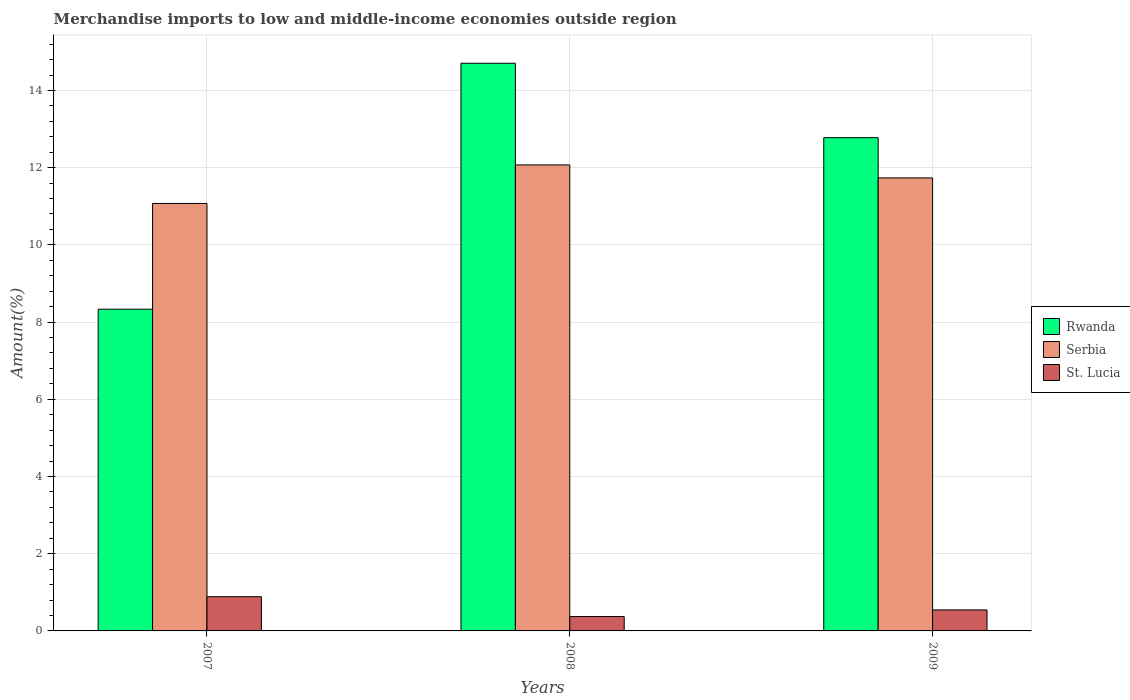How many different coloured bars are there?
Your response must be concise. 3. Are the number of bars per tick equal to the number of legend labels?
Your answer should be compact. Yes. Are the number of bars on each tick of the X-axis equal?
Provide a short and direct response. Yes. How many bars are there on the 1st tick from the left?
Give a very brief answer. 3. How many bars are there on the 2nd tick from the right?
Offer a terse response. 3. What is the label of the 3rd group of bars from the left?
Offer a terse response. 2009. In how many cases, is the number of bars for a given year not equal to the number of legend labels?
Offer a terse response. 0. What is the percentage of amount earned from merchandise imports in St. Lucia in 2007?
Ensure brevity in your answer.  0.89. Across all years, what is the maximum percentage of amount earned from merchandise imports in St. Lucia?
Your answer should be very brief. 0.89. Across all years, what is the minimum percentage of amount earned from merchandise imports in Serbia?
Make the answer very short. 11.07. In which year was the percentage of amount earned from merchandise imports in Serbia minimum?
Ensure brevity in your answer.  2007. What is the total percentage of amount earned from merchandise imports in Serbia in the graph?
Your response must be concise. 34.88. What is the difference between the percentage of amount earned from merchandise imports in St. Lucia in 2008 and that in 2009?
Your response must be concise. -0.17. What is the difference between the percentage of amount earned from merchandise imports in St. Lucia in 2008 and the percentage of amount earned from merchandise imports in Rwanda in 2009?
Your answer should be very brief. -12.4. What is the average percentage of amount earned from merchandise imports in Serbia per year?
Provide a short and direct response. 11.63. In the year 2009, what is the difference between the percentage of amount earned from merchandise imports in Serbia and percentage of amount earned from merchandise imports in St. Lucia?
Provide a succinct answer. 11.19. What is the ratio of the percentage of amount earned from merchandise imports in Rwanda in 2008 to that in 2009?
Provide a succinct answer. 1.15. Is the difference between the percentage of amount earned from merchandise imports in Serbia in 2007 and 2009 greater than the difference between the percentage of amount earned from merchandise imports in St. Lucia in 2007 and 2009?
Provide a succinct answer. No. What is the difference between the highest and the second highest percentage of amount earned from merchandise imports in Rwanda?
Your response must be concise. 1.93. What is the difference between the highest and the lowest percentage of amount earned from merchandise imports in Rwanda?
Make the answer very short. 6.37. In how many years, is the percentage of amount earned from merchandise imports in St. Lucia greater than the average percentage of amount earned from merchandise imports in St. Lucia taken over all years?
Your answer should be compact. 1. Is the sum of the percentage of amount earned from merchandise imports in St. Lucia in 2007 and 2008 greater than the maximum percentage of amount earned from merchandise imports in Rwanda across all years?
Your response must be concise. No. What does the 3rd bar from the left in 2008 represents?
Your answer should be compact. St. Lucia. What does the 1st bar from the right in 2008 represents?
Offer a terse response. St. Lucia. What is the difference between two consecutive major ticks on the Y-axis?
Offer a terse response. 2. Are the values on the major ticks of Y-axis written in scientific E-notation?
Your response must be concise. No. Does the graph contain any zero values?
Your answer should be very brief. No. Where does the legend appear in the graph?
Offer a terse response. Center right. How many legend labels are there?
Provide a succinct answer. 3. What is the title of the graph?
Offer a terse response. Merchandise imports to low and middle-income economies outside region. What is the label or title of the Y-axis?
Your answer should be very brief. Amount(%). What is the Amount(%) in Rwanda in 2007?
Ensure brevity in your answer.  8.33. What is the Amount(%) in Serbia in 2007?
Give a very brief answer. 11.07. What is the Amount(%) in St. Lucia in 2007?
Make the answer very short. 0.89. What is the Amount(%) in Rwanda in 2008?
Your answer should be very brief. 14.7. What is the Amount(%) in Serbia in 2008?
Give a very brief answer. 12.07. What is the Amount(%) in St. Lucia in 2008?
Your response must be concise. 0.37. What is the Amount(%) of Rwanda in 2009?
Ensure brevity in your answer.  12.78. What is the Amount(%) in Serbia in 2009?
Your answer should be very brief. 11.73. What is the Amount(%) of St. Lucia in 2009?
Make the answer very short. 0.54. Across all years, what is the maximum Amount(%) in Rwanda?
Keep it short and to the point. 14.7. Across all years, what is the maximum Amount(%) in Serbia?
Provide a short and direct response. 12.07. Across all years, what is the maximum Amount(%) in St. Lucia?
Provide a succinct answer. 0.89. Across all years, what is the minimum Amount(%) in Rwanda?
Offer a terse response. 8.33. Across all years, what is the minimum Amount(%) of Serbia?
Provide a succinct answer. 11.07. Across all years, what is the minimum Amount(%) of St. Lucia?
Your answer should be very brief. 0.37. What is the total Amount(%) of Rwanda in the graph?
Offer a very short reply. 35.81. What is the total Amount(%) of Serbia in the graph?
Your answer should be very brief. 34.88. What is the total Amount(%) of St. Lucia in the graph?
Your response must be concise. 1.8. What is the difference between the Amount(%) in Rwanda in 2007 and that in 2008?
Provide a short and direct response. -6.37. What is the difference between the Amount(%) of Serbia in 2007 and that in 2008?
Make the answer very short. -1. What is the difference between the Amount(%) in St. Lucia in 2007 and that in 2008?
Offer a very short reply. 0.51. What is the difference between the Amount(%) of Rwanda in 2007 and that in 2009?
Make the answer very short. -4.44. What is the difference between the Amount(%) in Serbia in 2007 and that in 2009?
Provide a short and direct response. -0.66. What is the difference between the Amount(%) in St. Lucia in 2007 and that in 2009?
Ensure brevity in your answer.  0.34. What is the difference between the Amount(%) in Rwanda in 2008 and that in 2009?
Your answer should be very brief. 1.93. What is the difference between the Amount(%) of Serbia in 2008 and that in 2009?
Your answer should be compact. 0.34. What is the difference between the Amount(%) of St. Lucia in 2008 and that in 2009?
Offer a terse response. -0.17. What is the difference between the Amount(%) in Rwanda in 2007 and the Amount(%) in Serbia in 2008?
Make the answer very short. -3.74. What is the difference between the Amount(%) of Rwanda in 2007 and the Amount(%) of St. Lucia in 2008?
Your answer should be very brief. 7.96. What is the difference between the Amount(%) in Serbia in 2007 and the Amount(%) in St. Lucia in 2008?
Ensure brevity in your answer.  10.7. What is the difference between the Amount(%) of Rwanda in 2007 and the Amount(%) of Serbia in 2009?
Give a very brief answer. -3.4. What is the difference between the Amount(%) in Rwanda in 2007 and the Amount(%) in St. Lucia in 2009?
Give a very brief answer. 7.79. What is the difference between the Amount(%) of Serbia in 2007 and the Amount(%) of St. Lucia in 2009?
Keep it short and to the point. 10.53. What is the difference between the Amount(%) of Rwanda in 2008 and the Amount(%) of Serbia in 2009?
Make the answer very short. 2.97. What is the difference between the Amount(%) of Rwanda in 2008 and the Amount(%) of St. Lucia in 2009?
Provide a succinct answer. 14.16. What is the difference between the Amount(%) in Serbia in 2008 and the Amount(%) in St. Lucia in 2009?
Provide a succinct answer. 11.53. What is the average Amount(%) of Rwanda per year?
Your answer should be compact. 11.94. What is the average Amount(%) in Serbia per year?
Offer a terse response. 11.63. What is the average Amount(%) in St. Lucia per year?
Offer a terse response. 0.6. In the year 2007, what is the difference between the Amount(%) of Rwanda and Amount(%) of Serbia?
Offer a very short reply. -2.74. In the year 2007, what is the difference between the Amount(%) of Rwanda and Amount(%) of St. Lucia?
Offer a terse response. 7.45. In the year 2007, what is the difference between the Amount(%) of Serbia and Amount(%) of St. Lucia?
Keep it short and to the point. 10.19. In the year 2008, what is the difference between the Amount(%) in Rwanda and Amount(%) in Serbia?
Offer a very short reply. 2.63. In the year 2008, what is the difference between the Amount(%) of Rwanda and Amount(%) of St. Lucia?
Provide a succinct answer. 14.33. In the year 2008, what is the difference between the Amount(%) in Serbia and Amount(%) in St. Lucia?
Your answer should be very brief. 11.7. In the year 2009, what is the difference between the Amount(%) in Rwanda and Amount(%) in Serbia?
Provide a succinct answer. 1.04. In the year 2009, what is the difference between the Amount(%) in Rwanda and Amount(%) in St. Lucia?
Make the answer very short. 12.23. In the year 2009, what is the difference between the Amount(%) in Serbia and Amount(%) in St. Lucia?
Provide a short and direct response. 11.19. What is the ratio of the Amount(%) of Rwanda in 2007 to that in 2008?
Ensure brevity in your answer.  0.57. What is the ratio of the Amount(%) in Serbia in 2007 to that in 2008?
Ensure brevity in your answer.  0.92. What is the ratio of the Amount(%) of St. Lucia in 2007 to that in 2008?
Your response must be concise. 2.38. What is the ratio of the Amount(%) of Rwanda in 2007 to that in 2009?
Provide a short and direct response. 0.65. What is the ratio of the Amount(%) of Serbia in 2007 to that in 2009?
Offer a very short reply. 0.94. What is the ratio of the Amount(%) of St. Lucia in 2007 to that in 2009?
Offer a terse response. 1.63. What is the ratio of the Amount(%) in Rwanda in 2008 to that in 2009?
Your response must be concise. 1.15. What is the ratio of the Amount(%) in Serbia in 2008 to that in 2009?
Keep it short and to the point. 1.03. What is the ratio of the Amount(%) of St. Lucia in 2008 to that in 2009?
Offer a very short reply. 0.68. What is the difference between the highest and the second highest Amount(%) of Rwanda?
Keep it short and to the point. 1.93. What is the difference between the highest and the second highest Amount(%) in Serbia?
Make the answer very short. 0.34. What is the difference between the highest and the second highest Amount(%) of St. Lucia?
Provide a short and direct response. 0.34. What is the difference between the highest and the lowest Amount(%) in Rwanda?
Make the answer very short. 6.37. What is the difference between the highest and the lowest Amount(%) in St. Lucia?
Offer a very short reply. 0.51. 